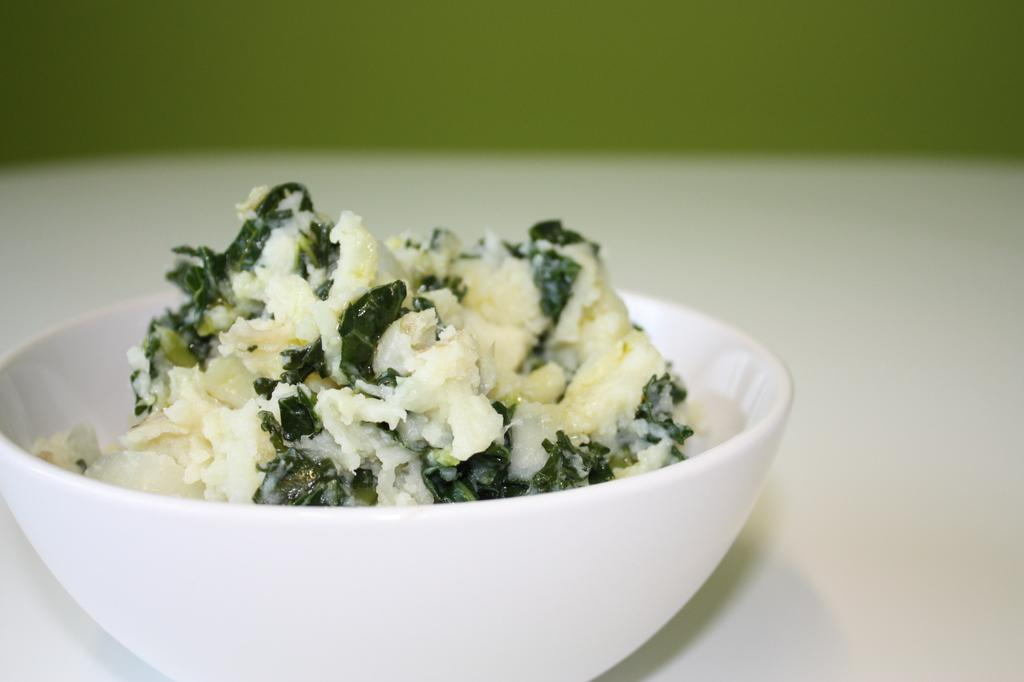What is in the bowl that is visible in the image? There is a food item in the bowl in the image. How many spiders are crawling on the food item in the image? There are no spiders present in the image; it only shows a bowl with a food item. What month is depicted in the image? The image does not depict a month; it only shows a bowl with a food item. 